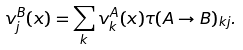Convert formula to latex. <formula><loc_0><loc_0><loc_500><loc_500>v _ { j } ^ { B } ( x ) = \sum _ { k } v _ { k } ^ { A } ( x ) \tau ( A \to B ) _ { k j } .</formula> 